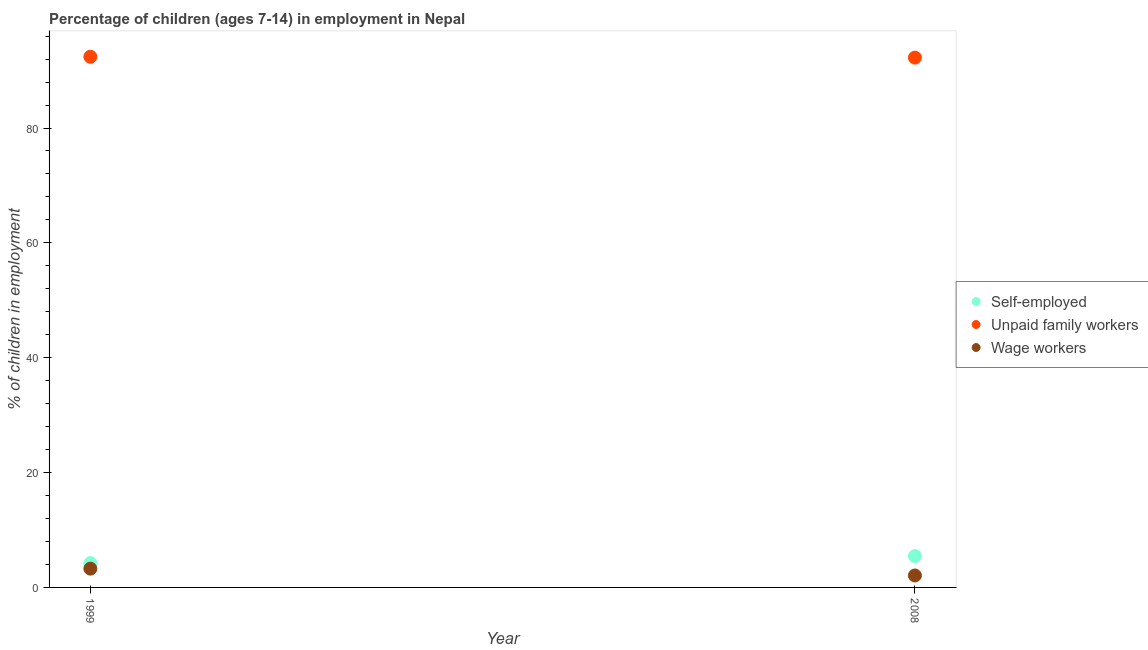How many different coloured dotlines are there?
Make the answer very short. 3. Is the number of dotlines equal to the number of legend labels?
Keep it short and to the point. Yes. What is the percentage of children employed as wage workers in 1999?
Your response must be concise. 3.27. Across all years, what is the maximum percentage of self employed children?
Make the answer very short. 5.46. Across all years, what is the minimum percentage of children employed as wage workers?
Your response must be concise. 2.08. In which year was the percentage of children employed as unpaid family workers maximum?
Make the answer very short. 1999. In which year was the percentage of self employed children minimum?
Give a very brief answer. 1999. What is the total percentage of children employed as unpaid family workers in the graph?
Provide a succinct answer. 184.67. What is the difference between the percentage of children employed as wage workers in 1999 and that in 2008?
Your answer should be compact. 1.19. What is the difference between the percentage of children employed as wage workers in 1999 and the percentage of self employed children in 2008?
Give a very brief answer. -2.19. What is the average percentage of children employed as unpaid family workers per year?
Give a very brief answer. 92.34. In the year 2008, what is the difference between the percentage of self employed children and percentage of children employed as wage workers?
Ensure brevity in your answer.  3.38. What is the ratio of the percentage of children employed as wage workers in 1999 to that in 2008?
Make the answer very short. 1.57. In how many years, is the percentage of children employed as unpaid family workers greater than the average percentage of children employed as unpaid family workers taken over all years?
Your answer should be compact. 1. Is the percentage of self employed children strictly less than the percentage of children employed as wage workers over the years?
Make the answer very short. No. How many dotlines are there?
Your answer should be very brief. 3. Are the values on the major ticks of Y-axis written in scientific E-notation?
Offer a terse response. No. Does the graph contain any zero values?
Provide a succinct answer. No. Does the graph contain grids?
Offer a very short reply. No. What is the title of the graph?
Keep it short and to the point. Percentage of children (ages 7-14) in employment in Nepal. What is the label or title of the Y-axis?
Make the answer very short. % of children in employment. What is the % of children in employment of Self-employed in 1999?
Provide a short and direct response. 4.23. What is the % of children in employment in Unpaid family workers in 1999?
Offer a terse response. 92.41. What is the % of children in employment in Wage workers in 1999?
Your response must be concise. 3.27. What is the % of children in employment in Self-employed in 2008?
Make the answer very short. 5.46. What is the % of children in employment of Unpaid family workers in 2008?
Offer a terse response. 92.26. What is the % of children in employment in Wage workers in 2008?
Provide a succinct answer. 2.08. Across all years, what is the maximum % of children in employment of Self-employed?
Make the answer very short. 5.46. Across all years, what is the maximum % of children in employment of Unpaid family workers?
Keep it short and to the point. 92.41. Across all years, what is the maximum % of children in employment of Wage workers?
Your response must be concise. 3.27. Across all years, what is the minimum % of children in employment of Self-employed?
Your response must be concise. 4.23. Across all years, what is the minimum % of children in employment of Unpaid family workers?
Give a very brief answer. 92.26. Across all years, what is the minimum % of children in employment in Wage workers?
Your answer should be very brief. 2.08. What is the total % of children in employment of Self-employed in the graph?
Provide a short and direct response. 9.69. What is the total % of children in employment of Unpaid family workers in the graph?
Keep it short and to the point. 184.67. What is the total % of children in employment in Wage workers in the graph?
Your response must be concise. 5.35. What is the difference between the % of children in employment of Self-employed in 1999 and that in 2008?
Your answer should be very brief. -1.23. What is the difference between the % of children in employment in Unpaid family workers in 1999 and that in 2008?
Provide a succinct answer. 0.15. What is the difference between the % of children in employment in Wage workers in 1999 and that in 2008?
Your answer should be very brief. 1.19. What is the difference between the % of children in employment of Self-employed in 1999 and the % of children in employment of Unpaid family workers in 2008?
Keep it short and to the point. -88.03. What is the difference between the % of children in employment in Self-employed in 1999 and the % of children in employment in Wage workers in 2008?
Offer a terse response. 2.15. What is the difference between the % of children in employment in Unpaid family workers in 1999 and the % of children in employment in Wage workers in 2008?
Keep it short and to the point. 90.33. What is the average % of children in employment of Self-employed per year?
Keep it short and to the point. 4.84. What is the average % of children in employment in Unpaid family workers per year?
Provide a short and direct response. 92.33. What is the average % of children in employment of Wage workers per year?
Your response must be concise. 2.67. In the year 1999, what is the difference between the % of children in employment of Self-employed and % of children in employment of Unpaid family workers?
Offer a very short reply. -88.18. In the year 1999, what is the difference between the % of children in employment in Unpaid family workers and % of children in employment in Wage workers?
Make the answer very short. 89.14. In the year 2008, what is the difference between the % of children in employment of Self-employed and % of children in employment of Unpaid family workers?
Make the answer very short. -86.8. In the year 2008, what is the difference between the % of children in employment of Self-employed and % of children in employment of Wage workers?
Give a very brief answer. 3.38. In the year 2008, what is the difference between the % of children in employment in Unpaid family workers and % of children in employment in Wage workers?
Offer a terse response. 90.18. What is the ratio of the % of children in employment in Self-employed in 1999 to that in 2008?
Provide a short and direct response. 0.77. What is the ratio of the % of children in employment in Wage workers in 1999 to that in 2008?
Provide a short and direct response. 1.57. What is the difference between the highest and the second highest % of children in employment of Self-employed?
Ensure brevity in your answer.  1.23. What is the difference between the highest and the second highest % of children in employment of Unpaid family workers?
Your answer should be compact. 0.15. What is the difference between the highest and the second highest % of children in employment in Wage workers?
Offer a very short reply. 1.19. What is the difference between the highest and the lowest % of children in employment in Self-employed?
Provide a succinct answer. 1.23. What is the difference between the highest and the lowest % of children in employment of Unpaid family workers?
Ensure brevity in your answer.  0.15. What is the difference between the highest and the lowest % of children in employment of Wage workers?
Make the answer very short. 1.19. 